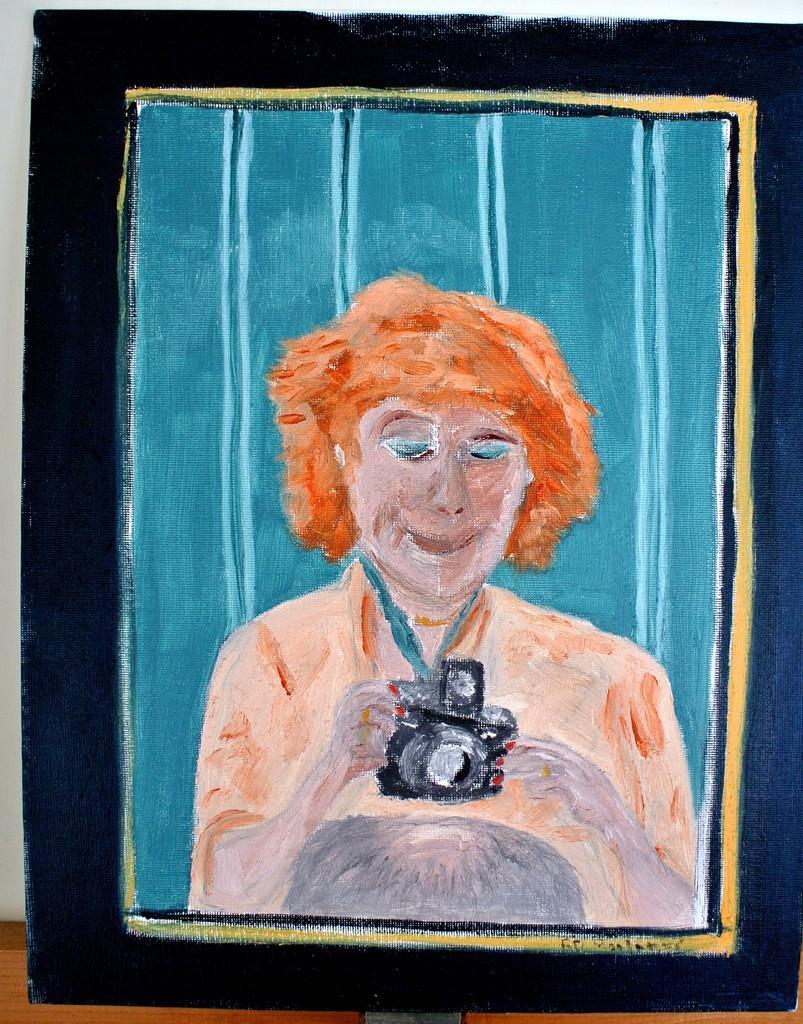Please provide a concise description of this image. This image consists of a painting sheet. Hear I can see a painting of a person who is holding camera in hands and looking at the camera. 